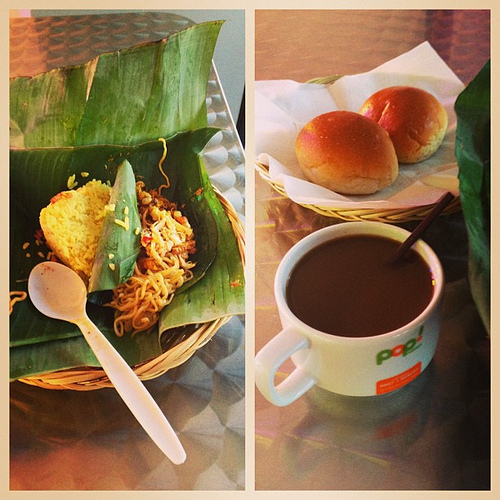What are the buns in? The golden-brown buns, looking soft and freshly baked, are presented in the same type of basket as the noodles, amplifying the homely, cozy dining setting. 